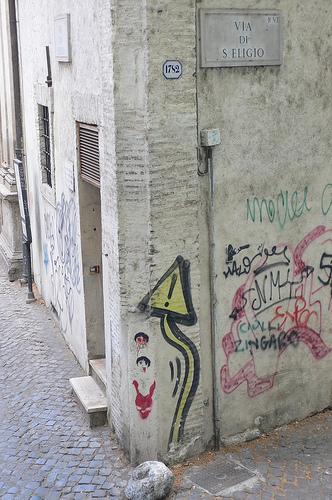What way does the arrow point?
Answer briefly. Up. What animal is painted on the wall?
Concise answer only. None. What can be seen all the way around the building?
Be succinct. Graffiti. How many stairs are there?
Keep it brief. 2. Is the trash can gray?
Give a very brief answer. No. What shape has an exclamation mark inside it?
Concise answer only. Triangle. 